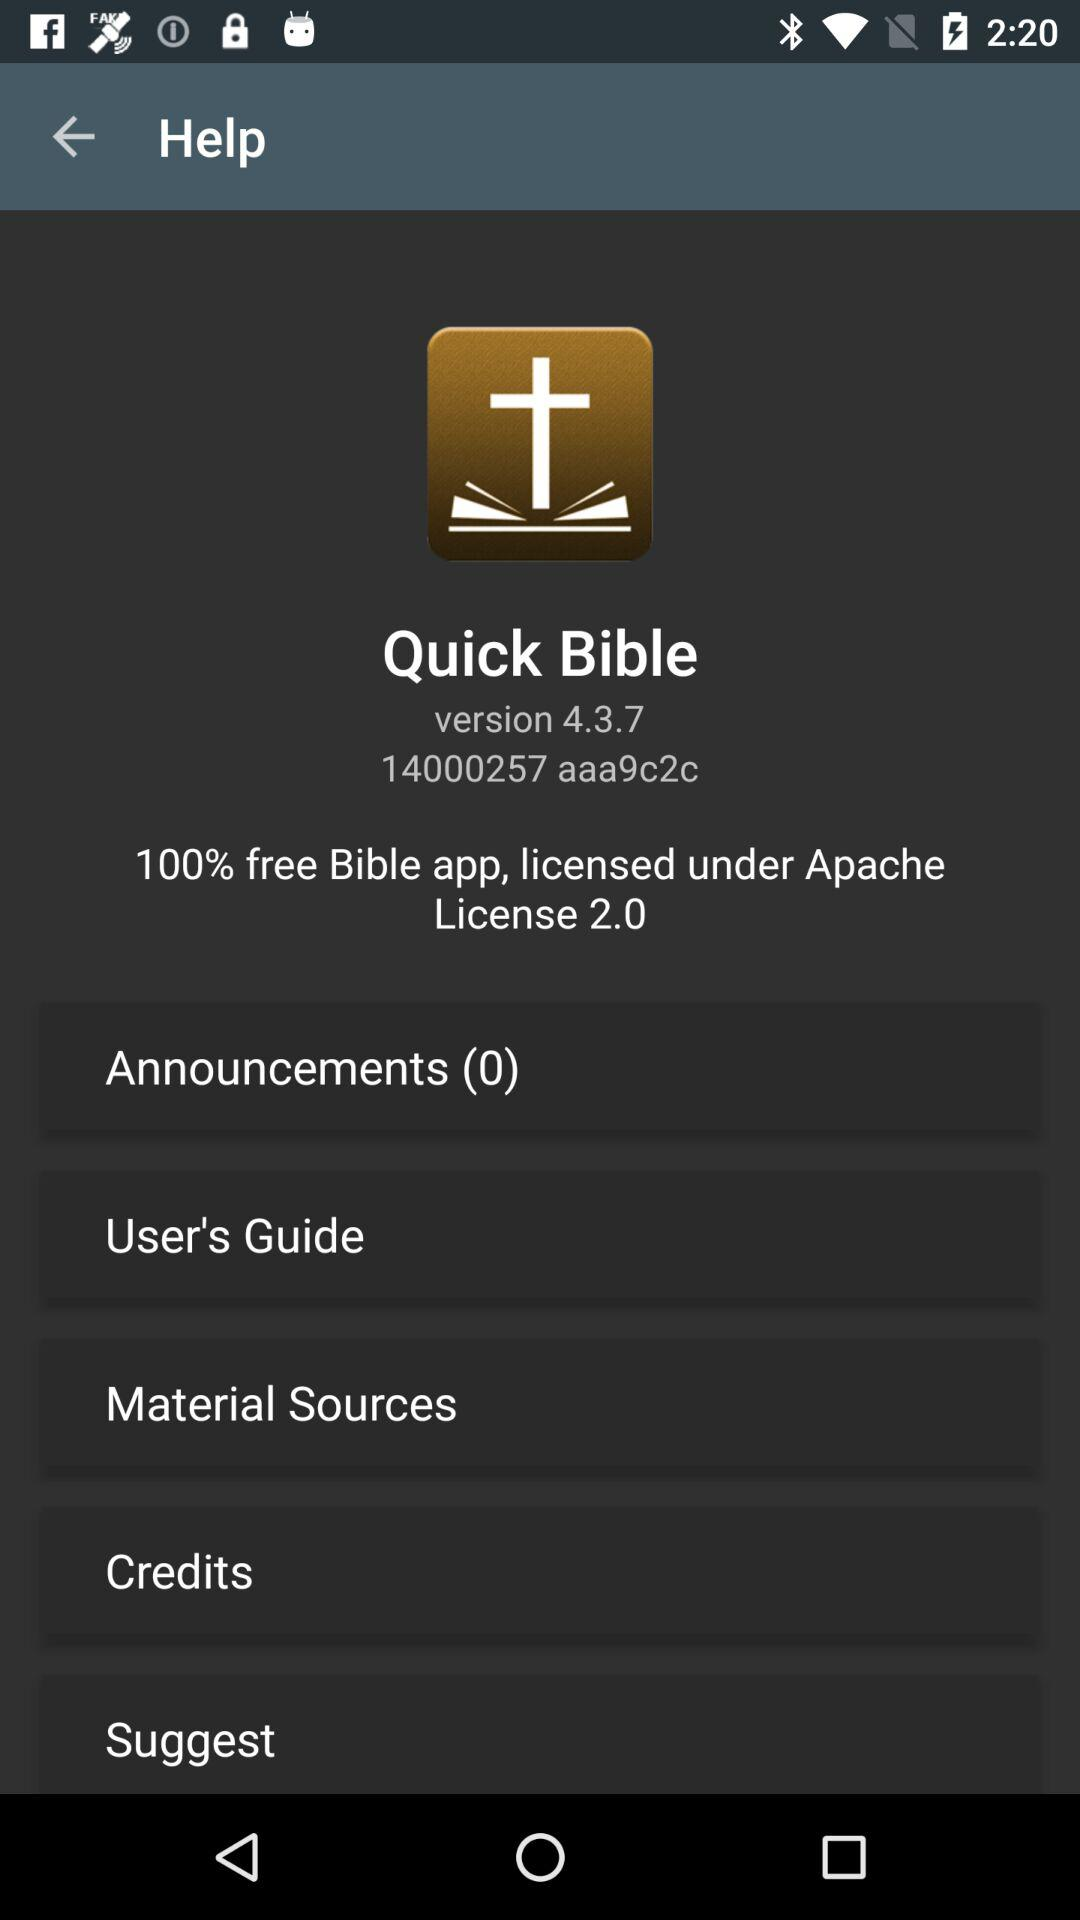What is the version of this application? The version is 4.3.7. 